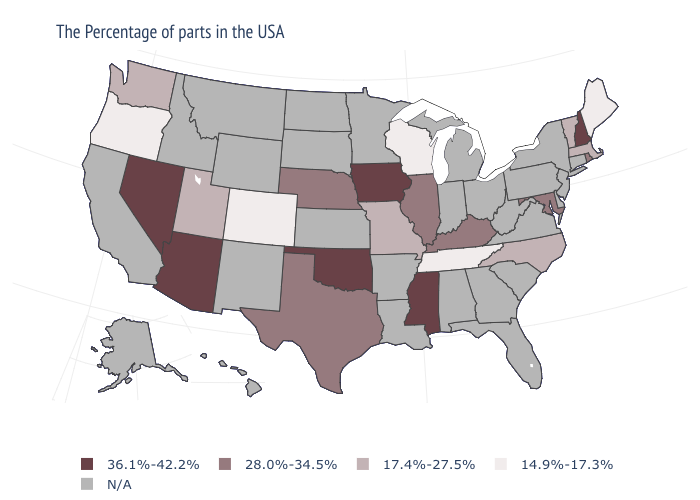Which states have the lowest value in the Northeast?
Keep it brief. Maine. How many symbols are there in the legend?
Answer briefly. 5. What is the highest value in states that border Oregon?
Answer briefly. 36.1%-42.2%. What is the value of Alabama?
Keep it brief. N/A. Does the first symbol in the legend represent the smallest category?
Give a very brief answer. No. Which states have the lowest value in the USA?
Quick response, please. Maine, Tennessee, Wisconsin, Colorado, Oregon. Name the states that have a value in the range 28.0%-34.5%?
Concise answer only. Rhode Island, Maryland, Kentucky, Illinois, Nebraska, Texas. What is the lowest value in the USA?
Write a very short answer. 14.9%-17.3%. Name the states that have a value in the range 14.9%-17.3%?
Write a very short answer. Maine, Tennessee, Wisconsin, Colorado, Oregon. Does Iowa have the lowest value in the MidWest?
Answer briefly. No. Name the states that have a value in the range 36.1%-42.2%?
Answer briefly. New Hampshire, Mississippi, Iowa, Oklahoma, Arizona, Nevada. What is the value of Alaska?
Concise answer only. N/A. What is the value of Florida?
Give a very brief answer. N/A. Name the states that have a value in the range 17.4%-27.5%?
Short answer required. Massachusetts, Vermont, North Carolina, Missouri, Utah, Washington. 